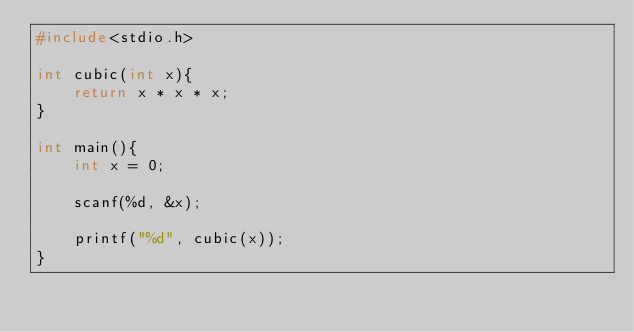Convert code to text. <code><loc_0><loc_0><loc_500><loc_500><_C_>#include<stdio.h>

int cubic(int x){
	return x * x * x;
}

int main(){
	int x = 0;

	scanf(%d, &x);

	printf("%d", cubic(x));
}</code> 